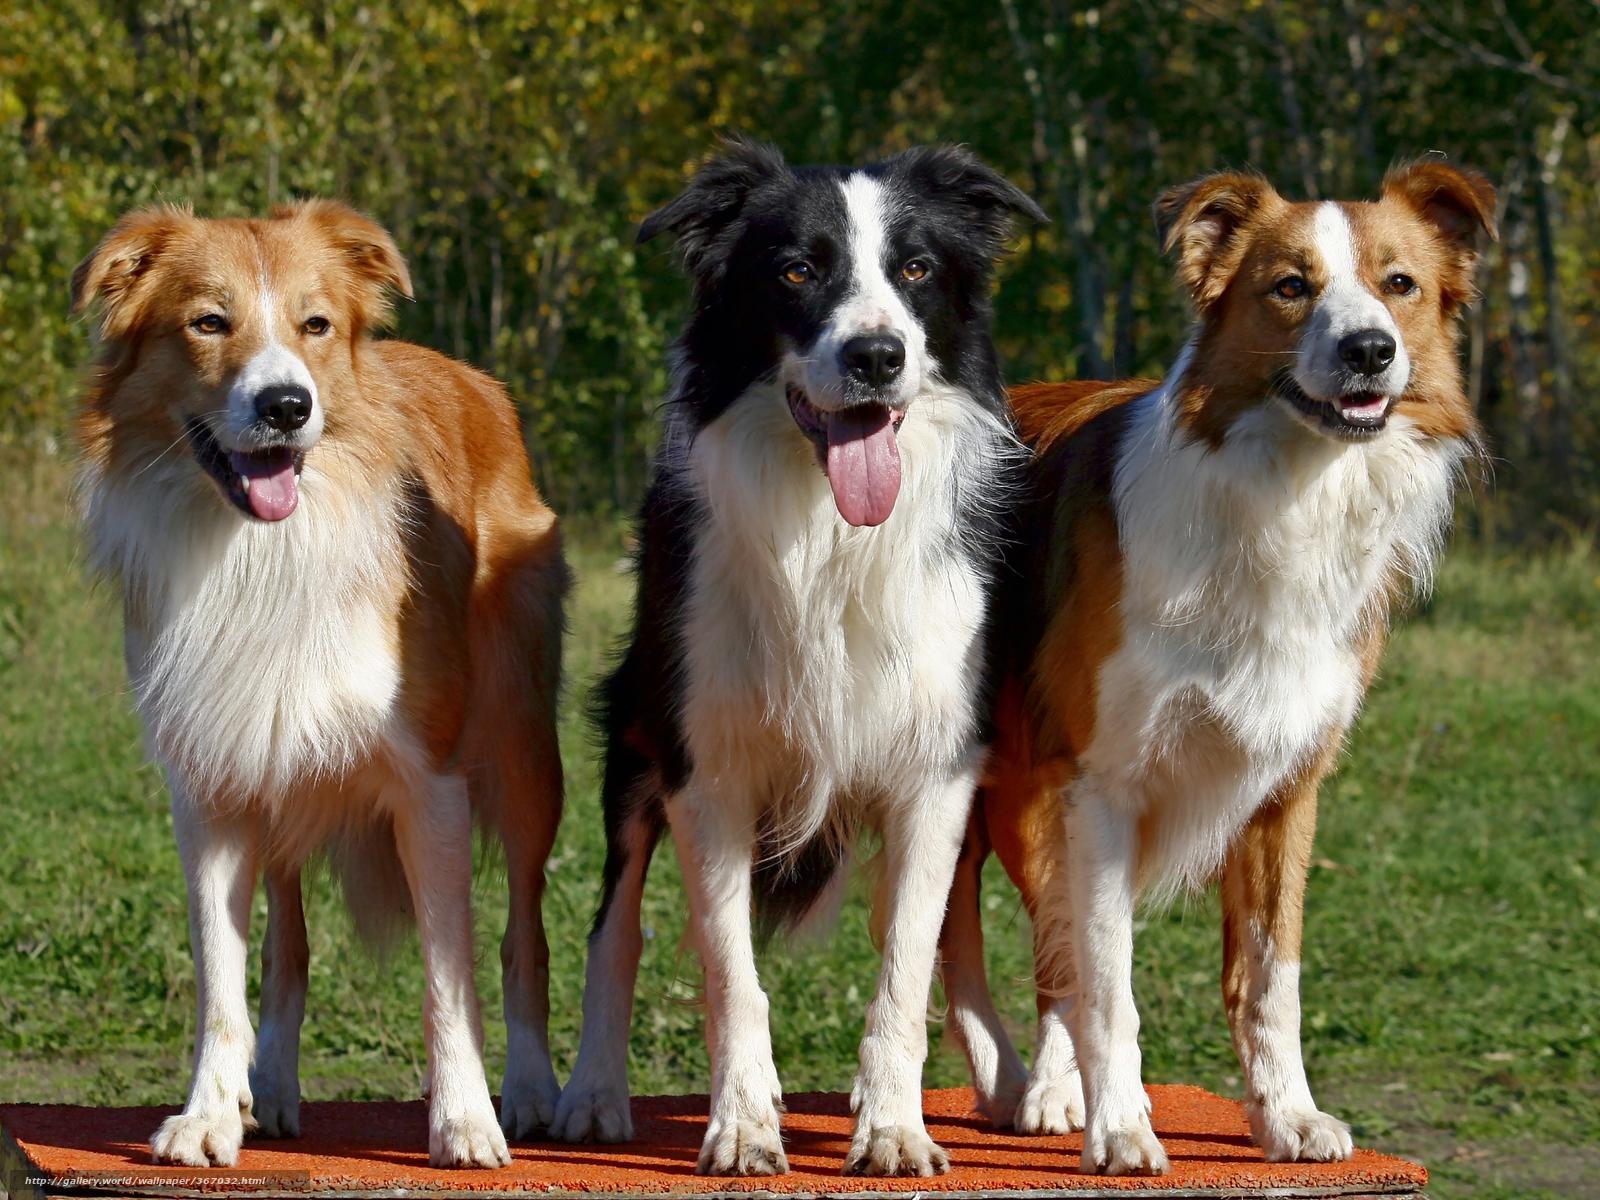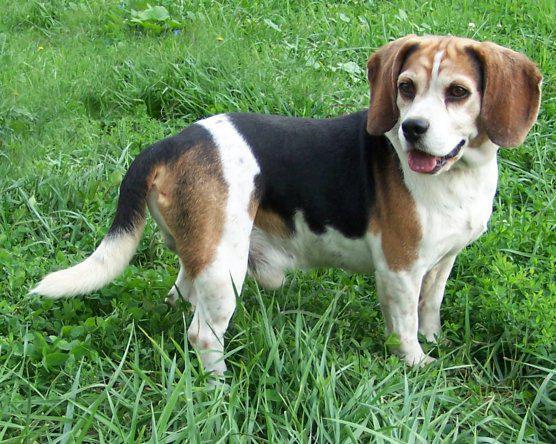The first image is the image on the left, the second image is the image on the right. Assess this claim about the two images: "There is at least two dogs in the left image.". Correct or not? Answer yes or no. Yes. The first image is the image on the left, the second image is the image on the right. Evaluate the accuracy of this statement regarding the images: "Each image contains one beagle standing on all fours with its tail up, and the beagle on the right wears a red collar.". Is it true? Answer yes or no. No. 